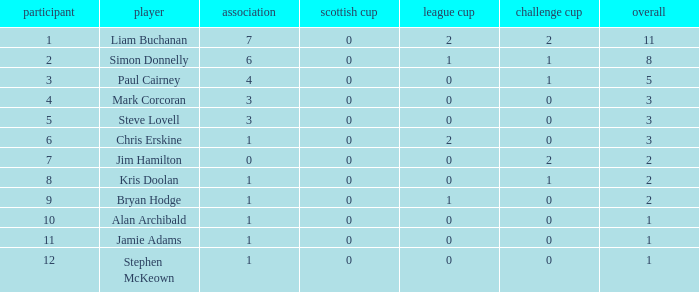What was the lowest number of points scored in the league cup? 0.0. Would you be able to parse every entry in this table? {'header': ['participant', 'player', 'association', 'scottish cup', 'league cup', 'challenge cup', 'overall'], 'rows': [['1', 'Liam Buchanan', '7', '0', '2', '2', '11'], ['2', 'Simon Donnelly', '6', '0', '1', '1', '8'], ['3', 'Paul Cairney', '4', '0', '0', '1', '5'], ['4', 'Mark Corcoran', '3', '0', '0', '0', '3'], ['5', 'Steve Lovell', '3', '0', '0', '0', '3'], ['6', 'Chris Erskine', '1', '0', '2', '0', '3'], ['7', 'Jim Hamilton', '0', '0', '0', '2', '2'], ['8', 'Kris Doolan', '1', '0', '0', '1', '2'], ['9', 'Bryan Hodge', '1', '0', '1', '0', '2'], ['10', 'Alan Archibald', '1', '0', '0', '0', '1'], ['11', 'Jamie Adams', '1', '0', '0', '0', '1'], ['12', 'Stephen McKeown', '1', '0', '0', '0', '1']]} 